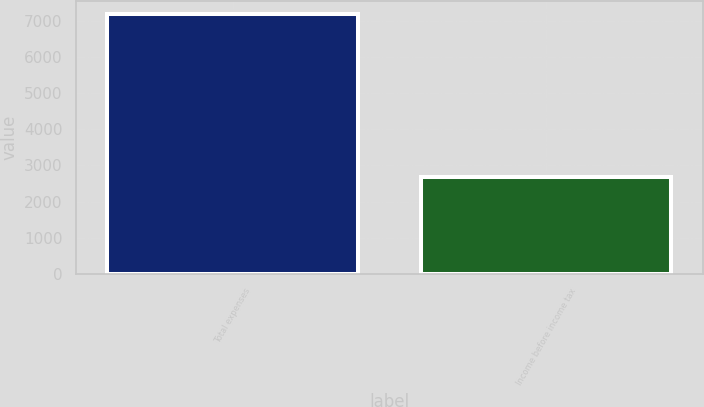Convert chart to OTSL. <chart><loc_0><loc_0><loc_500><loc_500><bar_chart><fcel>Total expenses<fcel>Income before income tax<nl><fcel>7192<fcel>2686<nl></chart> 